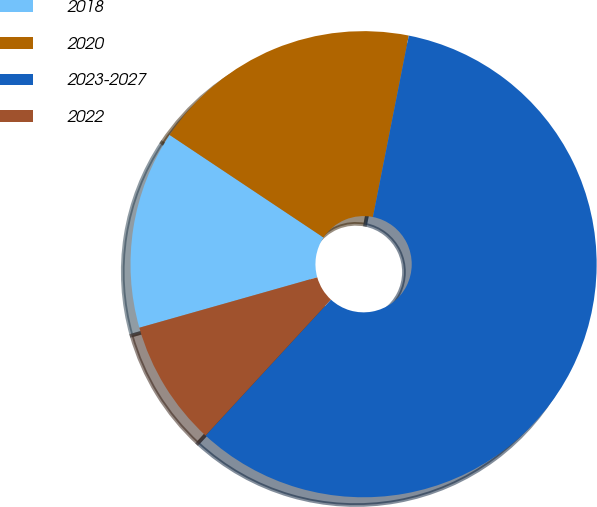Convert chart to OTSL. <chart><loc_0><loc_0><loc_500><loc_500><pie_chart><fcel>2018<fcel>2020<fcel>2023-2027<fcel>2022<nl><fcel>13.75%<fcel>18.75%<fcel>58.75%<fcel>8.75%<nl></chart> 